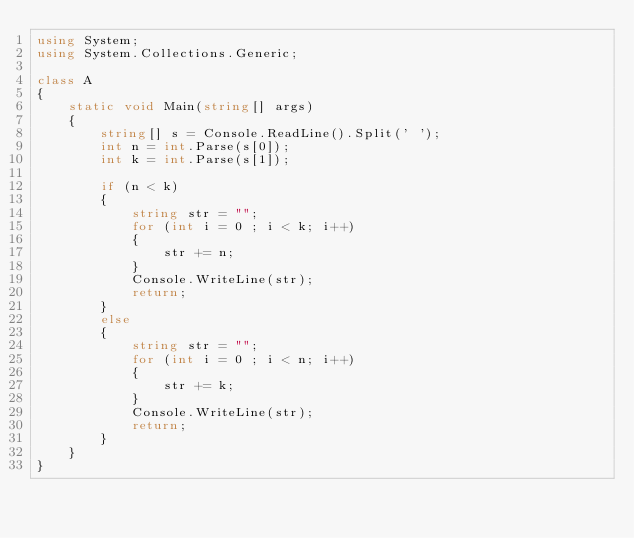Convert code to text. <code><loc_0><loc_0><loc_500><loc_500><_C#_>using System;
using System.Collections.Generic;

class A
{
    static void Main(string[] args)
    {
        string[] s = Console.ReadLine().Split(' ');
        int n = int.Parse(s[0]);
        int k = int.Parse(s[1]);

        if (n < k)
        {
            string str = "";
            for (int i = 0 ; i < k; i++)
            {
                str += n;
            }
            Console.WriteLine(str);
            return;
        }
        else
        {
            string str = "";
            for (int i = 0 ; i < n; i++)
            {
                str += k;
            }
            Console.WriteLine(str);
            return;            
        }
    }
}</code> 